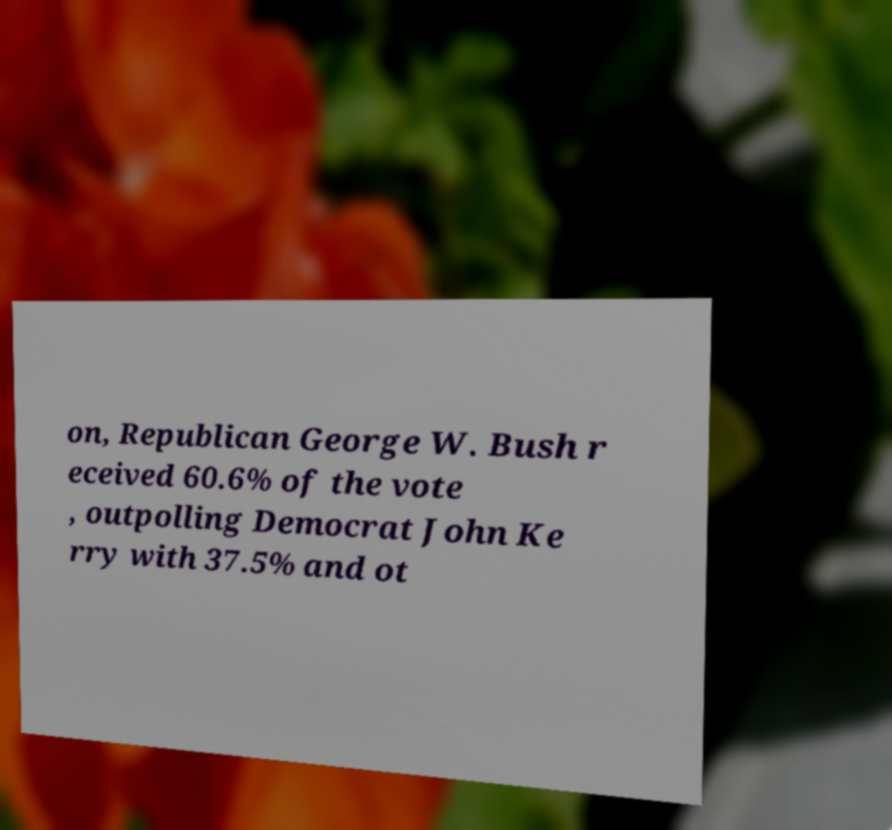I need the written content from this picture converted into text. Can you do that? on, Republican George W. Bush r eceived 60.6% of the vote , outpolling Democrat John Ke rry with 37.5% and ot 